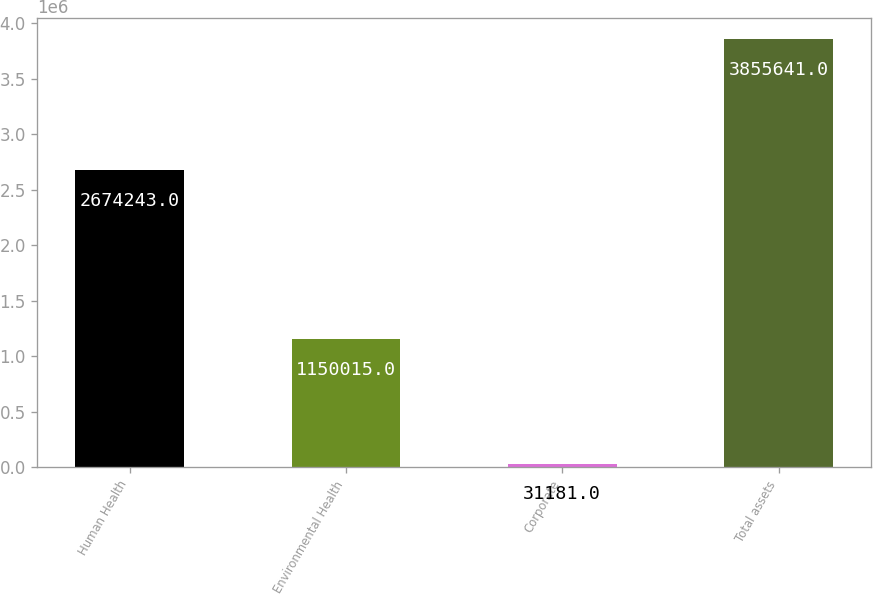<chart> <loc_0><loc_0><loc_500><loc_500><bar_chart><fcel>Human Health<fcel>Environmental Health<fcel>Corporate<fcel>Total assets<nl><fcel>2.67424e+06<fcel>1.15002e+06<fcel>31181<fcel>3.85564e+06<nl></chart> 